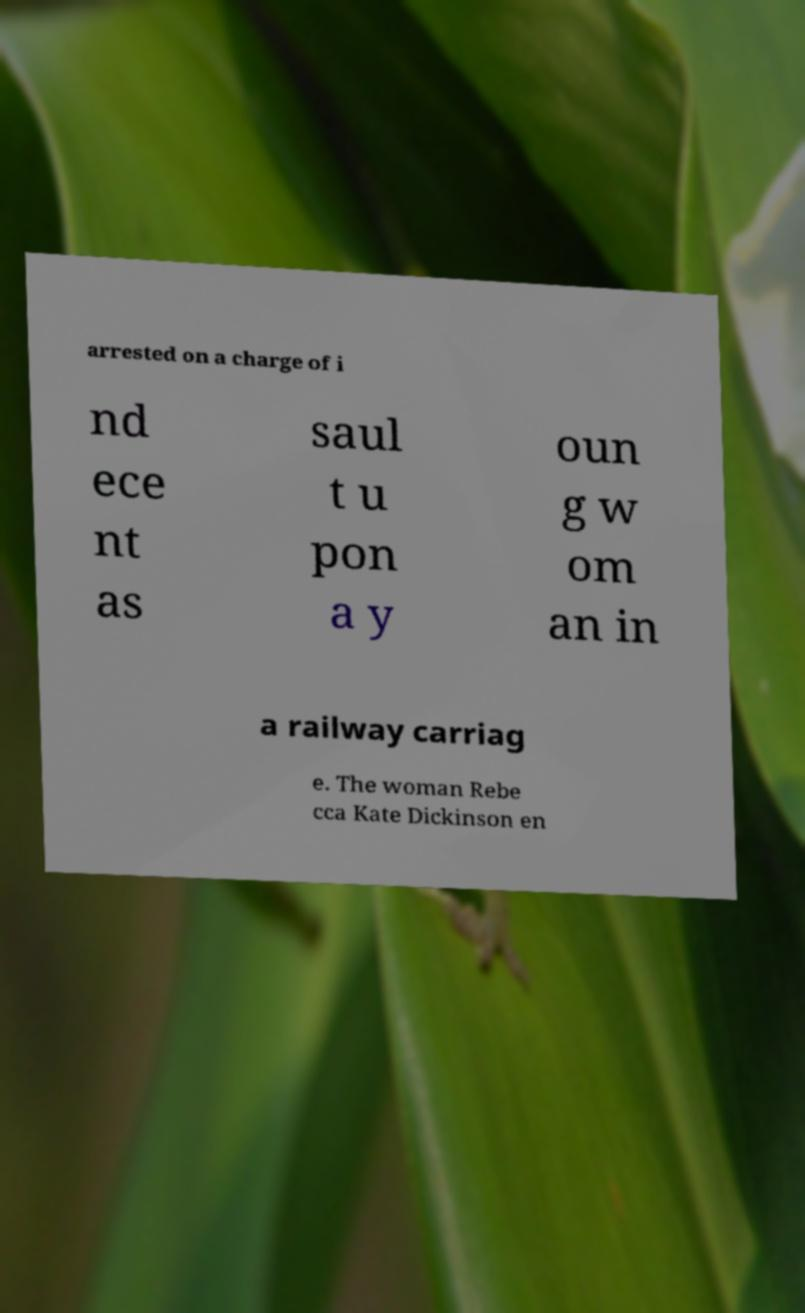For documentation purposes, I need the text within this image transcribed. Could you provide that? arrested on a charge of i nd ece nt as saul t u pon a y oun g w om an in a railway carriag e. The woman Rebe cca Kate Dickinson en 